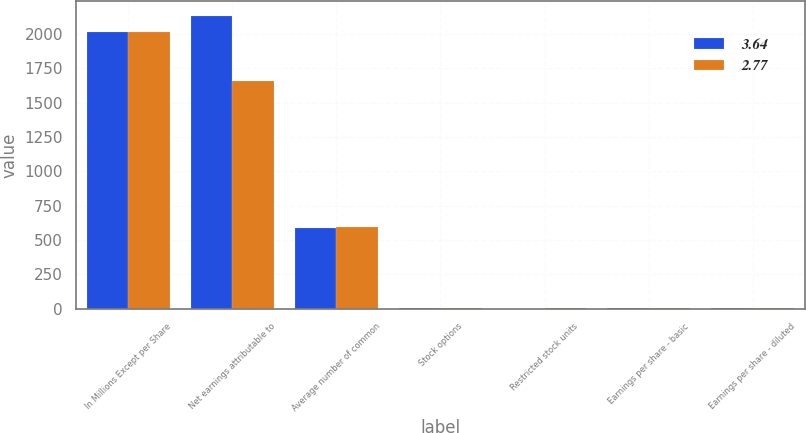Convert chart. <chart><loc_0><loc_0><loc_500><loc_500><stacked_bar_chart><ecel><fcel>In Millions Except per Share<fcel>Net earnings attributable to<fcel>Average number of common<fcel>Stock options<fcel>Restricted stock units<fcel>Earnings per share - basic<fcel>Earnings per share - diluted<nl><fcel>3.64<fcel>2018<fcel>2131<fcel>585.7<fcel>6.9<fcel>2<fcel>3.69<fcel>3.64<nl><fcel>2.77<fcel>2017<fcel>1657.5<fcel>598<fcel>8.1<fcel>2.8<fcel>2.82<fcel>2.77<nl></chart> 